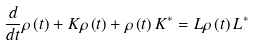<formula> <loc_0><loc_0><loc_500><loc_500>\frac { d } { d t } \rho \left ( t \right ) + K \rho \left ( t \right ) + \rho \left ( t \right ) K ^ { \ast } = L \rho \left ( t \right ) L ^ { \ast }</formula> 